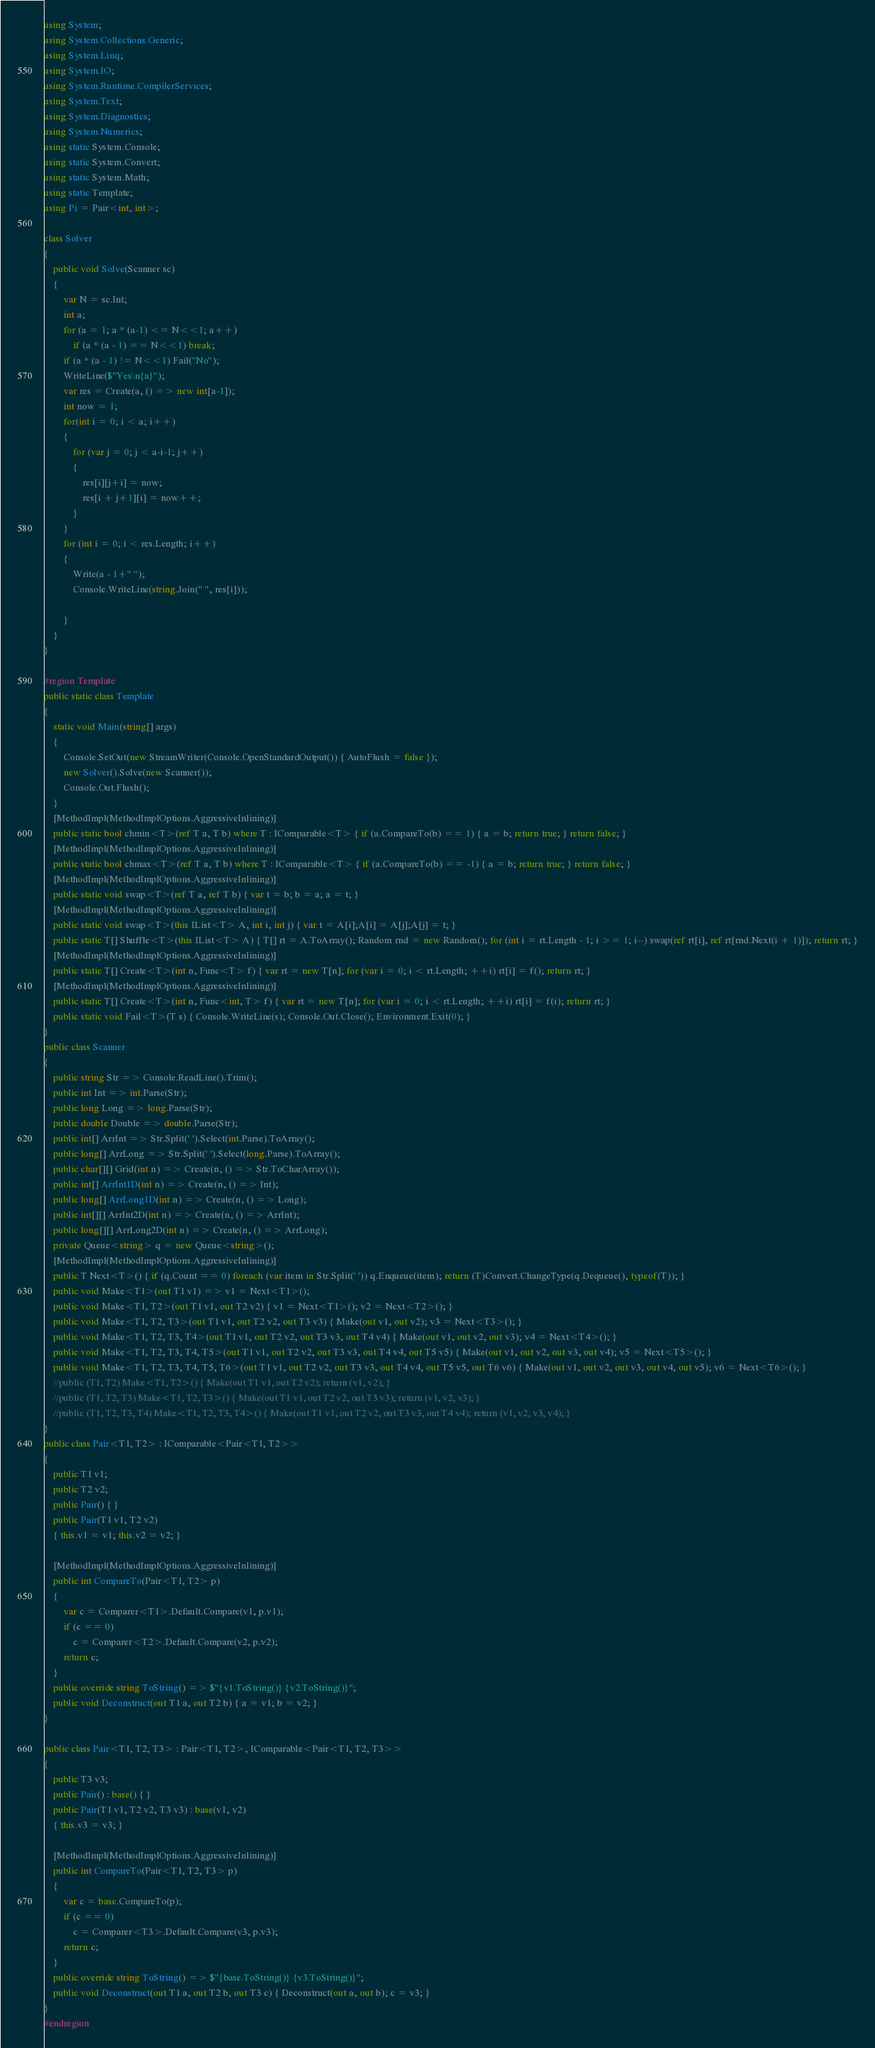<code> <loc_0><loc_0><loc_500><loc_500><_C#_>using System;
using System.Collections.Generic;
using System.Linq;
using System.IO;
using System.Runtime.CompilerServices;
using System.Text;
using System.Diagnostics;
using System.Numerics;
using static System.Console;
using static System.Convert;
using static System.Math;
using static Template;
using Pi = Pair<int, int>;

class Solver
{
    public void Solve(Scanner sc)
    {
        var N = sc.Int;
        int a;
        for (a = 1; a * (a-1) <= N<<1; a++)
            if (a * (a - 1) == N<<1) break;
        if (a * (a - 1) != N<<1) Fail("No");
        WriteLine($"Yes\n{a}");
        var res = Create(a, () => new int[a-1]);
        int now = 1;
        for(int i = 0; i < a; i++)
        {
            for (var j = 0; j < a-i-1; j++)
            {
                res[i][j+i] = now;
                res[i + j+1][i] = now++;
            }
        }
        for (int i = 0; i < res.Length; i++)
        {
            Write(a - 1+" ");
            Console.WriteLine(string.Join(" ", res[i]));

        }
    }
}

#region Template
public static class Template
{
    static void Main(string[] args)
    {
        Console.SetOut(new StreamWriter(Console.OpenStandardOutput()) { AutoFlush = false });
        new Solver().Solve(new Scanner());
        Console.Out.Flush();
    }
    [MethodImpl(MethodImplOptions.AggressiveInlining)]
    public static bool chmin<T>(ref T a, T b) where T : IComparable<T> { if (a.CompareTo(b) == 1) { a = b; return true; } return false; }
    [MethodImpl(MethodImplOptions.AggressiveInlining)]
    public static bool chmax<T>(ref T a, T b) where T : IComparable<T> { if (a.CompareTo(b) == -1) { a = b; return true; } return false; }
    [MethodImpl(MethodImplOptions.AggressiveInlining)]
    public static void swap<T>(ref T a, ref T b) { var t = b; b = a; a = t; }
    [MethodImpl(MethodImplOptions.AggressiveInlining)]
    public static void swap<T>(this IList<T> A, int i, int j) { var t = A[i];A[i] = A[j];A[j] = t; }
    public static T[] Shuffle<T>(this IList<T> A) { T[] rt = A.ToArray(); Random rnd = new Random(); for (int i = rt.Length - 1; i >= 1; i--) swap(ref rt[i], ref rt[rnd.Next(i + 1)]); return rt; }
    [MethodImpl(MethodImplOptions.AggressiveInlining)]
    public static T[] Create<T>(int n, Func<T> f) { var rt = new T[n]; for (var i = 0; i < rt.Length; ++i) rt[i] = f(); return rt; }
    [MethodImpl(MethodImplOptions.AggressiveInlining)]
    public static T[] Create<T>(int n, Func<int, T> f) { var rt = new T[n]; for (var i = 0; i < rt.Length; ++i) rt[i] = f(i); return rt; }
    public static void Fail<T>(T s) { Console.WriteLine(s); Console.Out.Close(); Environment.Exit(0); }
}
public class Scanner
{
    public string Str => Console.ReadLine().Trim();
    public int Int => int.Parse(Str);
    public long Long => long.Parse(Str);
    public double Double => double.Parse(Str);
    public int[] ArrInt => Str.Split(' ').Select(int.Parse).ToArray();
    public long[] ArrLong => Str.Split(' ').Select(long.Parse).ToArray();
    public char[][] Grid(int n) => Create(n, () => Str.ToCharArray());
    public int[] ArrInt1D(int n) => Create(n, () => Int);
    public long[] ArrLong1D(int n) => Create(n, () => Long);
    public int[][] ArrInt2D(int n) => Create(n, () => ArrInt);
    public long[][] ArrLong2D(int n) => Create(n, () => ArrLong);
    private Queue<string> q = new Queue<string>();
    [MethodImpl(MethodImplOptions.AggressiveInlining)]
    public T Next<T>() { if (q.Count == 0) foreach (var item in Str.Split(' ')) q.Enqueue(item); return (T)Convert.ChangeType(q.Dequeue(), typeof(T)); }
    public void Make<T1>(out T1 v1) => v1 = Next<T1>();
    public void Make<T1, T2>(out T1 v1, out T2 v2) { v1 = Next<T1>(); v2 = Next<T2>(); }
    public void Make<T1, T2, T3>(out T1 v1, out T2 v2, out T3 v3) { Make(out v1, out v2); v3 = Next<T3>(); }
    public void Make<T1, T2, T3, T4>(out T1 v1, out T2 v2, out T3 v3, out T4 v4) { Make(out v1, out v2, out v3); v4 = Next<T4>(); }
    public void Make<T1, T2, T3, T4, T5>(out T1 v1, out T2 v2, out T3 v3, out T4 v4, out T5 v5) { Make(out v1, out v2, out v3, out v4); v5 = Next<T5>(); }
    public void Make<T1, T2, T3, T4, T5, T6>(out T1 v1, out T2 v2, out T3 v3, out T4 v4, out T5 v5, out T6 v6) { Make(out v1, out v2, out v3, out v4, out v5); v6 = Next<T6>(); }
    //public (T1, T2) Make<T1, T2>() { Make(out T1 v1, out T2 v2); return (v1, v2); }
    //public (T1, T2, T3) Make<T1, T2, T3>() { Make(out T1 v1, out T2 v2, out T3 v3); return (v1, v2, v3); }
    //public (T1, T2, T3, T4) Make<T1, T2, T3, T4>() { Make(out T1 v1, out T2 v2, out T3 v3, out T4 v4); return (v1, v2, v3, v4); }
}
public class Pair<T1, T2> : IComparable<Pair<T1, T2>>
{
    public T1 v1;
    public T2 v2;
    public Pair() { }
    public Pair(T1 v1, T2 v2)
    { this.v1 = v1; this.v2 = v2; }

    [MethodImpl(MethodImplOptions.AggressiveInlining)]
    public int CompareTo(Pair<T1, T2> p)
    {
        var c = Comparer<T1>.Default.Compare(v1, p.v1);
        if (c == 0)
            c = Comparer<T2>.Default.Compare(v2, p.v2);
        return c;
    }
    public override string ToString() => $"{v1.ToString()} {v2.ToString()}";
    public void Deconstruct(out T1 a, out T2 b) { a = v1; b = v2; }
}

public class Pair<T1, T2, T3> : Pair<T1, T2>, IComparable<Pair<T1, T2, T3>>
{
    public T3 v3;
    public Pair() : base() { }
    public Pair(T1 v1, T2 v2, T3 v3) : base(v1, v2)
    { this.v3 = v3; }

    [MethodImpl(MethodImplOptions.AggressiveInlining)]
    public int CompareTo(Pair<T1, T2, T3> p)
    {
        var c = base.CompareTo(p);
        if (c == 0)
            c = Comparer<T3>.Default.Compare(v3, p.v3);
        return c;
    }
    public override string ToString() => $"{base.ToString()} {v3.ToString()}";
    public void Deconstruct(out T1 a, out T2 b, out T3 c) { Deconstruct(out a, out b); c = v3; }
}
#endregion</code> 